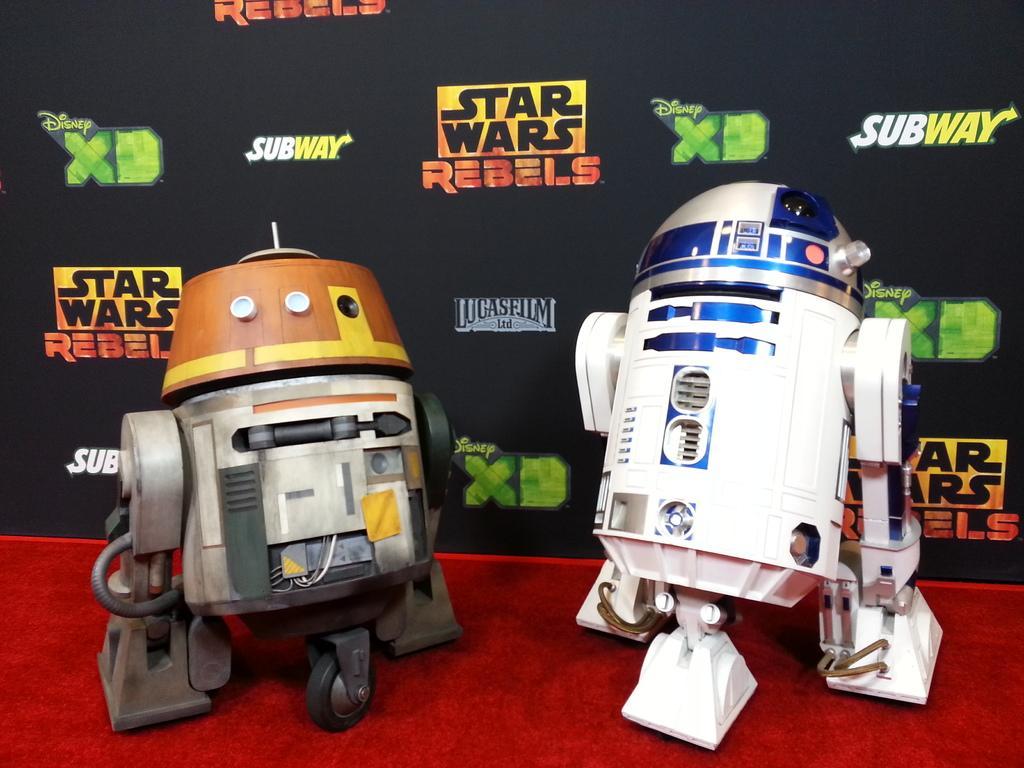In one or two sentences, can you explain what this image depicts? In this image in the front there are machines. In the background there is a banner with some text written on it and on the floor there is a red colour mat which is in the front. 